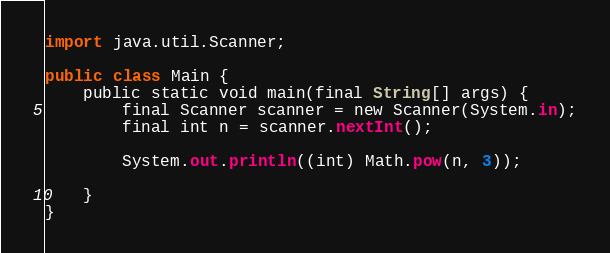Convert code to text. <code><loc_0><loc_0><loc_500><loc_500><_Kotlin_>
import java.util.Scanner;

public class Main {
    public static void main(final String[] args) {
        final Scanner scanner = new Scanner(System.in);
        final int n = scanner.nextInt();

        System.out.println((int) Math.pow(n, 3));

    }
}
</code> 